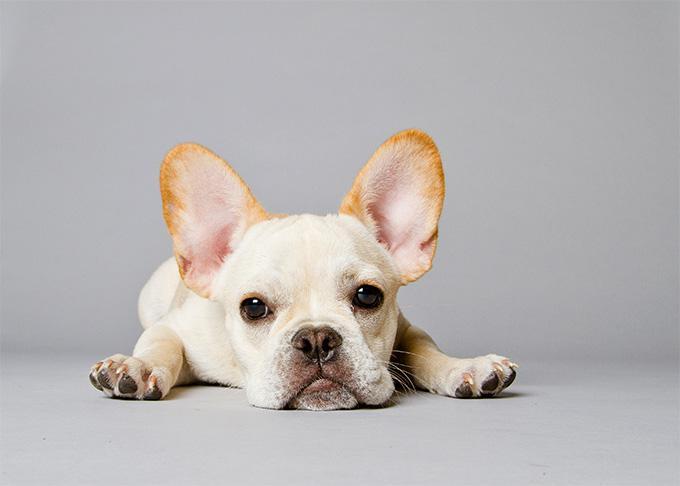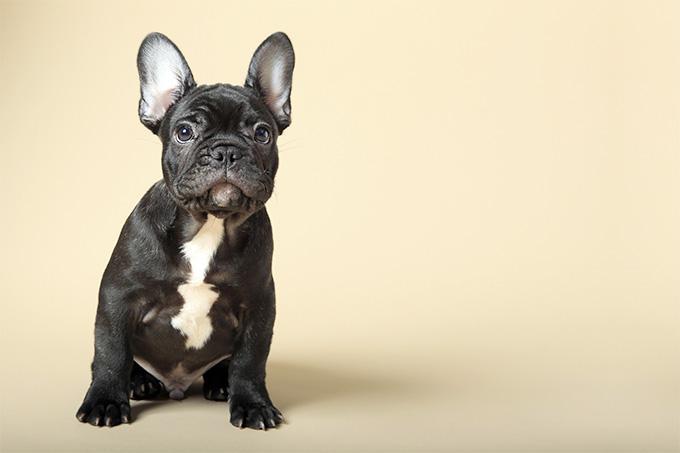The first image is the image on the left, the second image is the image on the right. For the images displayed, is the sentence "the pupply on the left image has its head laying flat on a surface" factually correct? Answer yes or no. Yes. 